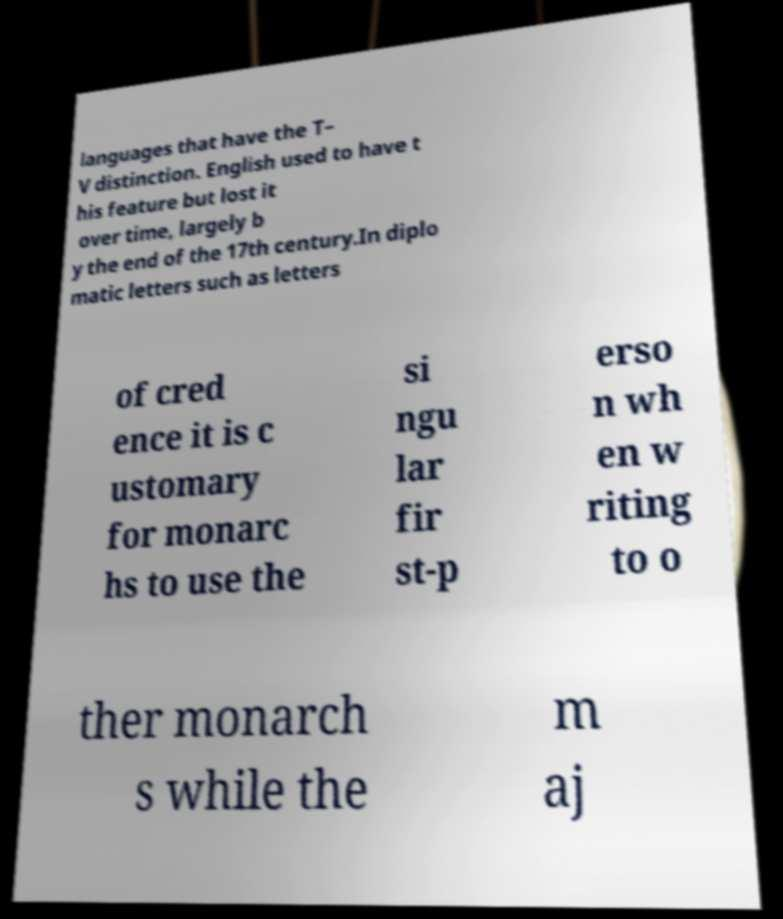For documentation purposes, I need the text within this image transcribed. Could you provide that? languages that have the T– V distinction. English used to have t his feature but lost it over time, largely b y the end of the 17th century.In diplo matic letters such as letters of cred ence it is c ustomary for monarc hs to use the si ngu lar fir st-p erso n wh en w riting to o ther monarch s while the m aj 